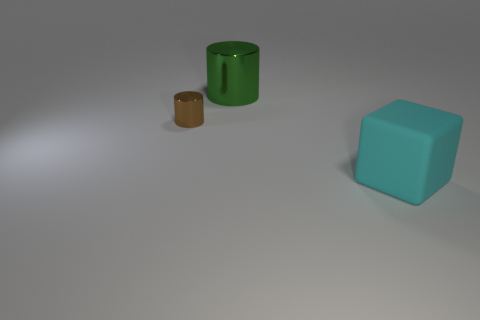Add 3 green cylinders. How many objects exist? 6 Subtract 1 cylinders. How many cylinders are left? 1 Subtract all red cylinders. Subtract all cyan spheres. How many cylinders are left? 2 Subtract all gray blocks. How many brown cylinders are left? 1 Subtract all big blocks. Subtract all matte cylinders. How many objects are left? 2 Add 3 large cyan matte objects. How many large cyan matte objects are left? 4 Add 1 small rubber things. How many small rubber things exist? 1 Subtract 0 gray spheres. How many objects are left? 3 Subtract all cylinders. How many objects are left? 1 